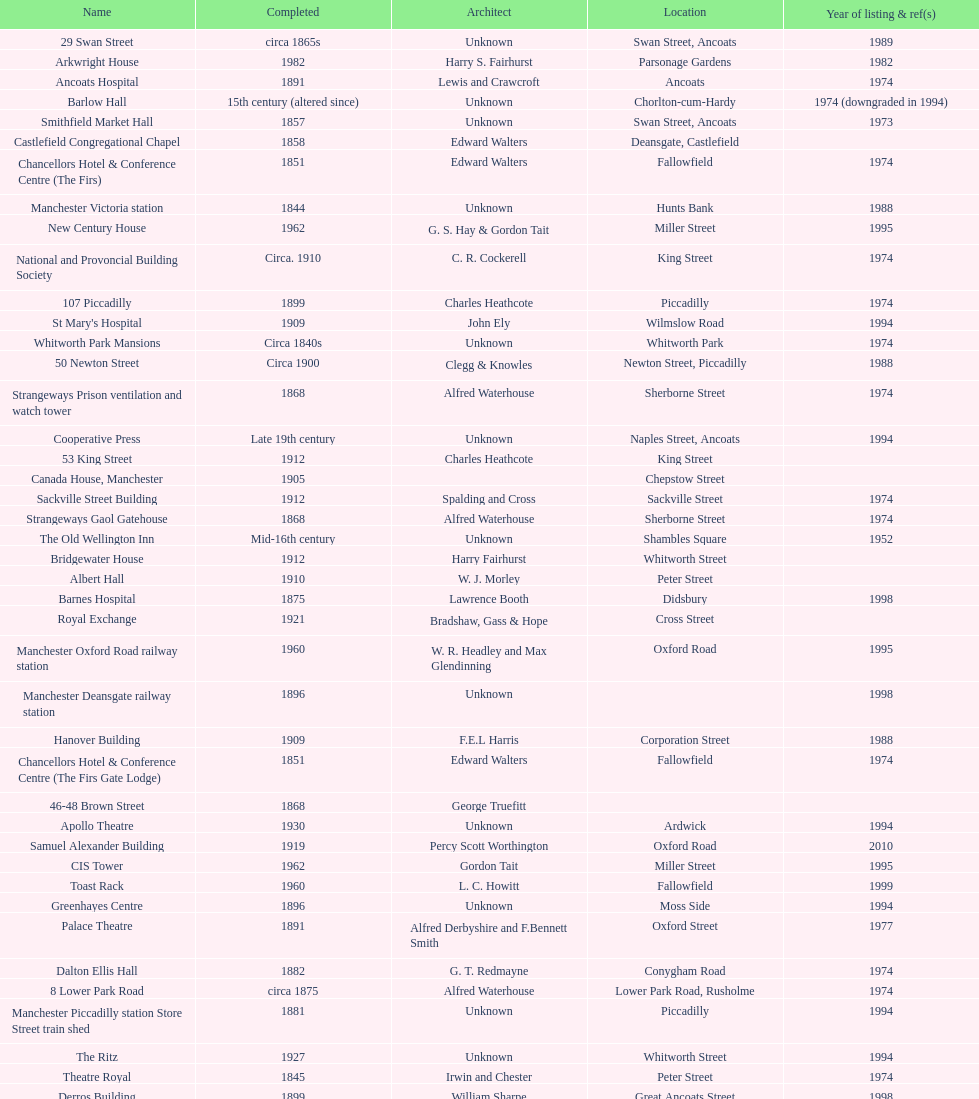What is the avenue of the unique building listed in 1989? Swan Street. 